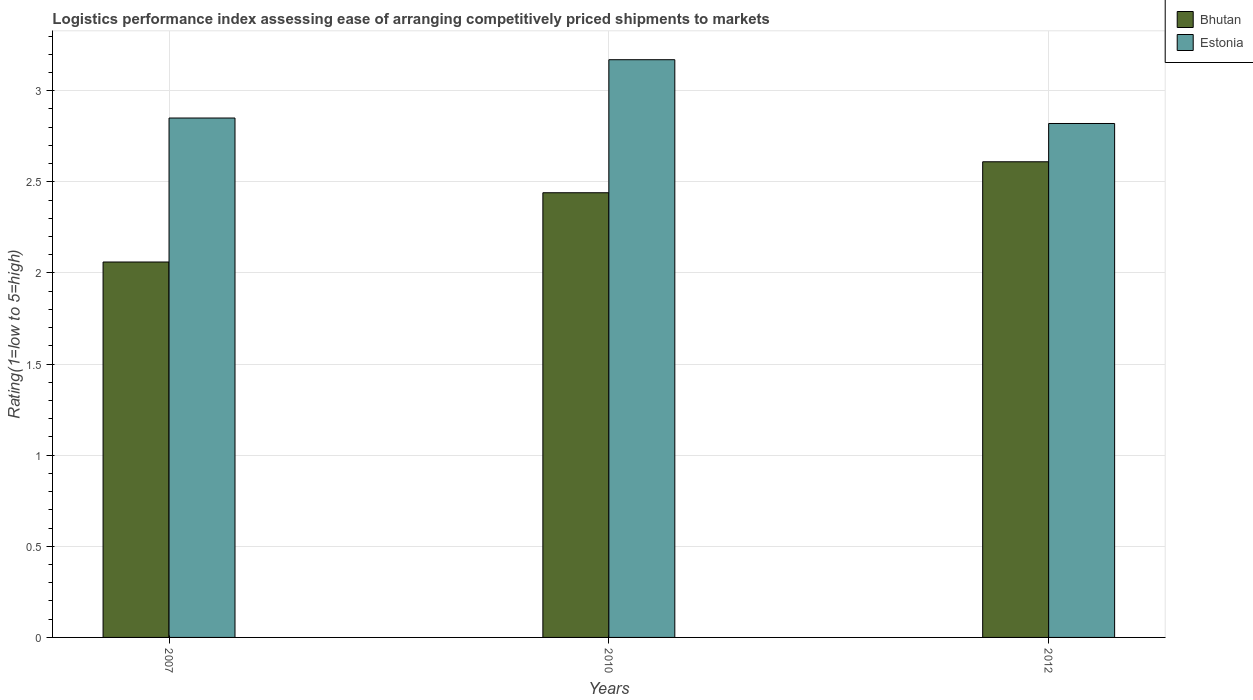How many different coloured bars are there?
Provide a short and direct response. 2. How many groups of bars are there?
Provide a succinct answer. 3. How many bars are there on the 2nd tick from the right?
Give a very brief answer. 2. What is the label of the 2nd group of bars from the left?
Give a very brief answer. 2010. In how many cases, is the number of bars for a given year not equal to the number of legend labels?
Your answer should be very brief. 0. What is the Logistic performance index in Estonia in 2010?
Ensure brevity in your answer.  3.17. Across all years, what is the maximum Logistic performance index in Bhutan?
Offer a terse response. 2.61. Across all years, what is the minimum Logistic performance index in Estonia?
Provide a succinct answer. 2.82. In which year was the Logistic performance index in Bhutan maximum?
Offer a terse response. 2012. What is the total Logistic performance index in Estonia in the graph?
Offer a terse response. 8.84. What is the difference between the Logistic performance index in Bhutan in 2010 and that in 2012?
Provide a short and direct response. -0.17. What is the difference between the Logistic performance index in Bhutan in 2010 and the Logistic performance index in Estonia in 2012?
Ensure brevity in your answer.  -0.38. What is the average Logistic performance index in Estonia per year?
Your answer should be compact. 2.95. In the year 2007, what is the difference between the Logistic performance index in Bhutan and Logistic performance index in Estonia?
Give a very brief answer. -0.79. In how many years, is the Logistic performance index in Estonia greater than 2.4?
Provide a short and direct response. 3. What is the ratio of the Logistic performance index in Bhutan in 2007 to that in 2012?
Offer a terse response. 0.79. Is the difference between the Logistic performance index in Bhutan in 2010 and 2012 greater than the difference between the Logistic performance index in Estonia in 2010 and 2012?
Your answer should be very brief. No. What is the difference between the highest and the second highest Logistic performance index in Estonia?
Ensure brevity in your answer.  0.32. What is the difference between the highest and the lowest Logistic performance index in Bhutan?
Keep it short and to the point. 0.55. In how many years, is the Logistic performance index in Estonia greater than the average Logistic performance index in Estonia taken over all years?
Ensure brevity in your answer.  1. What does the 2nd bar from the left in 2012 represents?
Provide a succinct answer. Estonia. What does the 2nd bar from the right in 2007 represents?
Make the answer very short. Bhutan. How many bars are there?
Provide a succinct answer. 6. Are all the bars in the graph horizontal?
Your answer should be very brief. No. How many years are there in the graph?
Your response must be concise. 3. Are the values on the major ticks of Y-axis written in scientific E-notation?
Your answer should be very brief. No. Does the graph contain any zero values?
Your answer should be very brief. No. Does the graph contain grids?
Keep it short and to the point. Yes. What is the title of the graph?
Give a very brief answer. Logistics performance index assessing ease of arranging competitively priced shipments to markets. Does "Canada" appear as one of the legend labels in the graph?
Offer a very short reply. No. What is the label or title of the Y-axis?
Provide a succinct answer. Rating(1=low to 5=high). What is the Rating(1=low to 5=high) in Bhutan in 2007?
Give a very brief answer. 2.06. What is the Rating(1=low to 5=high) in Estonia in 2007?
Your answer should be very brief. 2.85. What is the Rating(1=low to 5=high) of Bhutan in 2010?
Your answer should be compact. 2.44. What is the Rating(1=low to 5=high) of Estonia in 2010?
Ensure brevity in your answer.  3.17. What is the Rating(1=low to 5=high) of Bhutan in 2012?
Offer a terse response. 2.61. What is the Rating(1=low to 5=high) in Estonia in 2012?
Give a very brief answer. 2.82. Across all years, what is the maximum Rating(1=low to 5=high) of Bhutan?
Offer a very short reply. 2.61. Across all years, what is the maximum Rating(1=low to 5=high) of Estonia?
Give a very brief answer. 3.17. Across all years, what is the minimum Rating(1=low to 5=high) of Bhutan?
Make the answer very short. 2.06. Across all years, what is the minimum Rating(1=low to 5=high) in Estonia?
Your response must be concise. 2.82. What is the total Rating(1=low to 5=high) in Bhutan in the graph?
Your answer should be very brief. 7.11. What is the total Rating(1=low to 5=high) in Estonia in the graph?
Give a very brief answer. 8.84. What is the difference between the Rating(1=low to 5=high) in Bhutan in 2007 and that in 2010?
Ensure brevity in your answer.  -0.38. What is the difference between the Rating(1=low to 5=high) of Estonia in 2007 and that in 2010?
Provide a short and direct response. -0.32. What is the difference between the Rating(1=low to 5=high) in Bhutan in 2007 and that in 2012?
Your answer should be compact. -0.55. What is the difference between the Rating(1=low to 5=high) of Bhutan in 2010 and that in 2012?
Your answer should be very brief. -0.17. What is the difference between the Rating(1=low to 5=high) of Estonia in 2010 and that in 2012?
Offer a terse response. 0.35. What is the difference between the Rating(1=low to 5=high) of Bhutan in 2007 and the Rating(1=low to 5=high) of Estonia in 2010?
Your response must be concise. -1.11. What is the difference between the Rating(1=low to 5=high) of Bhutan in 2007 and the Rating(1=low to 5=high) of Estonia in 2012?
Your answer should be very brief. -0.76. What is the difference between the Rating(1=low to 5=high) in Bhutan in 2010 and the Rating(1=low to 5=high) in Estonia in 2012?
Your answer should be very brief. -0.38. What is the average Rating(1=low to 5=high) in Bhutan per year?
Offer a very short reply. 2.37. What is the average Rating(1=low to 5=high) in Estonia per year?
Your answer should be compact. 2.95. In the year 2007, what is the difference between the Rating(1=low to 5=high) in Bhutan and Rating(1=low to 5=high) in Estonia?
Make the answer very short. -0.79. In the year 2010, what is the difference between the Rating(1=low to 5=high) in Bhutan and Rating(1=low to 5=high) in Estonia?
Offer a terse response. -0.73. In the year 2012, what is the difference between the Rating(1=low to 5=high) of Bhutan and Rating(1=low to 5=high) of Estonia?
Ensure brevity in your answer.  -0.21. What is the ratio of the Rating(1=low to 5=high) of Bhutan in 2007 to that in 2010?
Provide a succinct answer. 0.84. What is the ratio of the Rating(1=low to 5=high) in Estonia in 2007 to that in 2010?
Your answer should be compact. 0.9. What is the ratio of the Rating(1=low to 5=high) in Bhutan in 2007 to that in 2012?
Keep it short and to the point. 0.79. What is the ratio of the Rating(1=low to 5=high) of Estonia in 2007 to that in 2012?
Keep it short and to the point. 1.01. What is the ratio of the Rating(1=low to 5=high) of Bhutan in 2010 to that in 2012?
Offer a terse response. 0.93. What is the ratio of the Rating(1=low to 5=high) in Estonia in 2010 to that in 2012?
Make the answer very short. 1.12. What is the difference between the highest and the second highest Rating(1=low to 5=high) of Bhutan?
Keep it short and to the point. 0.17. What is the difference between the highest and the second highest Rating(1=low to 5=high) of Estonia?
Your answer should be very brief. 0.32. What is the difference between the highest and the lowest Rating(1=low to 5=high) of Bhutan?
Offer a very short reply. 0.55. What is the difference between the highest and the lowest Rating(1=low to 5=high) of Estonia?
Offer a very short reply. 0.35. 